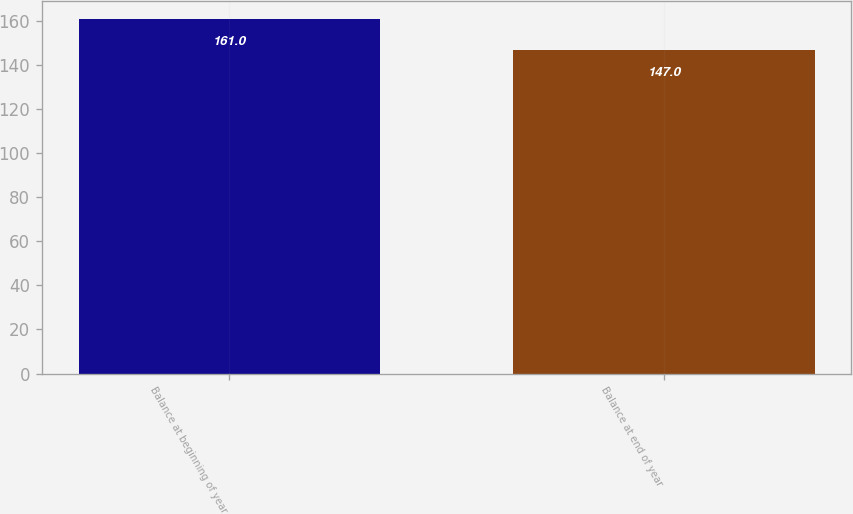<chart> <loc_0><loc_0><loc_500><loc_500><bar_chart><fcel>Balance at beginning of year<fcel>Balance at end of year<nl><fcel>161<fcel>147<nl></chart> 